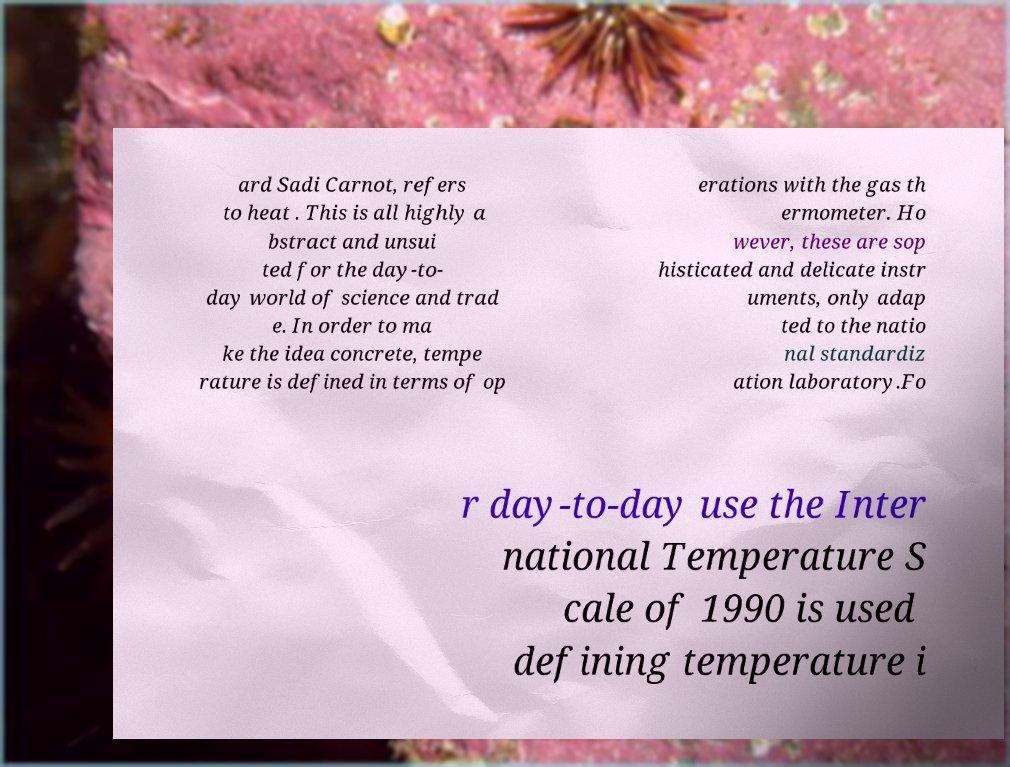Please identify and transcribe the text found in this image. ard Sadi Carnot, refers to heat . This is all highly a bstract and unsui ted for the day-to- day world of science and trad e. In order to ma ke the idea concrete, tempe rature is defined in terms of op erations with the gas th ermometer. Ho wever, these are sop histicated and delicate instr uments, only adap ted to the natio nal standardiz ation laboratory.Fo r day-to-day use the Inter national Temperature S cale of 1990 is used defining temperature i 